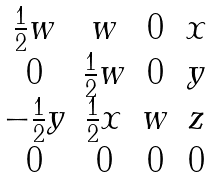Convert formula to latex. <formula><loc_0><loc_0><loc_500><loc_500>\begin{matrix} \frac { 1 } { 2 } w & w & 0 & x \\ 0 & \frac { 1 } { 2 } w & 0 & y \\ - \frac { 1 } { 2 } y & \frac { 1 } { 2 } x & w & z \\ 0 & 0 & 0 & 0 \end{matrix}</formula> 